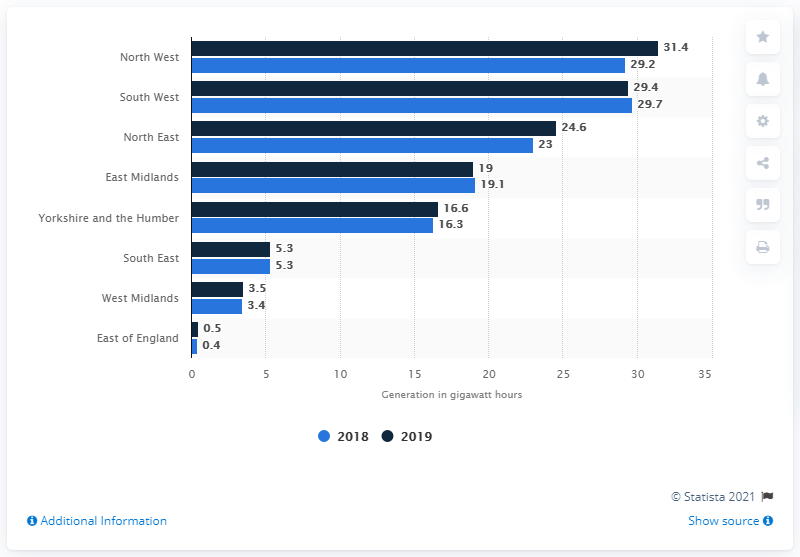Outline some significant characteristics in this image. The South West region had the highest amount of hydropower electricity generation. The North West region of England generated the most electricity from hydropower in 2019. The East of England region had the least amount of electricity generation in both 2018 and 2019. In the year 2019, the highest amount of electricity was generated. 